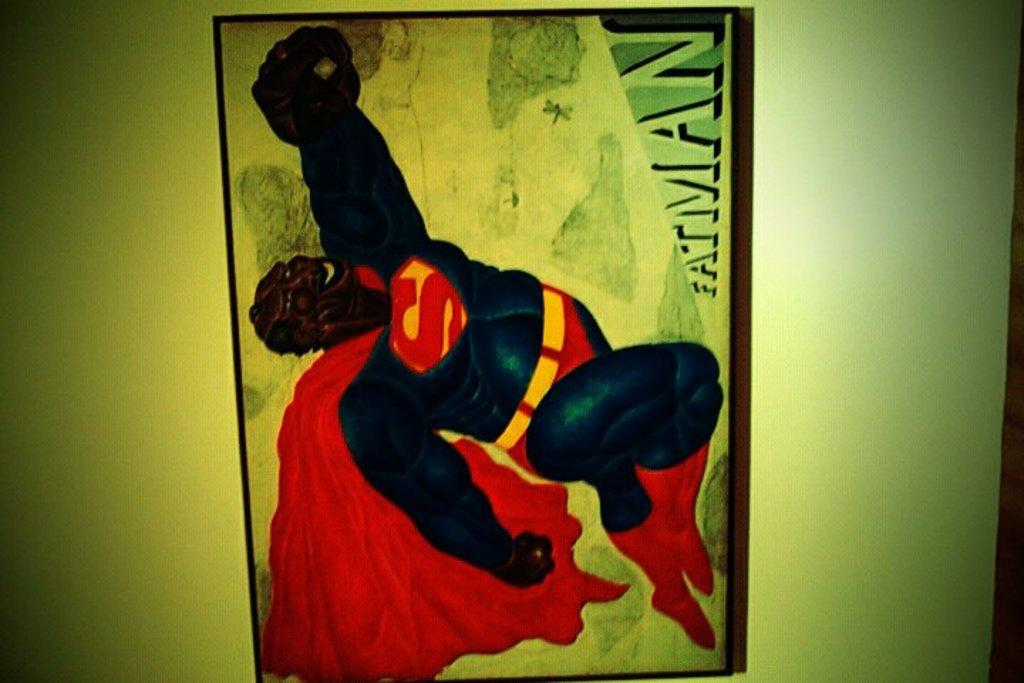<image>
Render a clear and concise summary of the photo. A man wearing superman's costume while there is a word Fatman on the corner. 